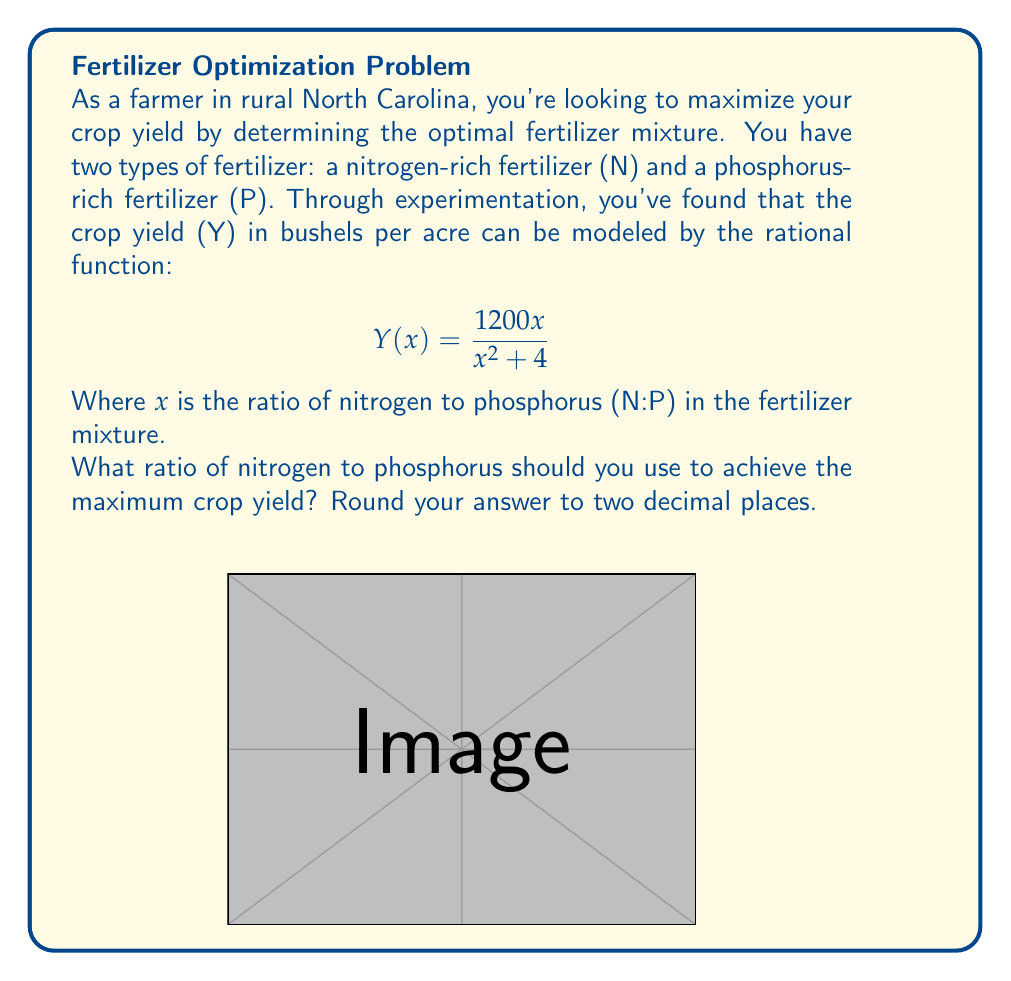Give your solution to this math problem. To find the maximum yield, we need to determine the x-value where the function Y(x) reaches its peak. We can do this by following these steps:

1) First, let's find the derivative of Y(x):
   $$ Y'(x) = \frac{(1200)(x^2 + 4) - 1200x(2x)}{(x^2 + 4)^2} $$
   $$ = \frac{1200x^2 + 4800 - 2400x^2}{(x^2 + 4)^2} $$
   $$ = \frac{4800 - 1200x^2}{(x^2 + 4)^2} $$

2) To find the maximum, set Y'(x) = 0 and solve for x:
   $$ \frac{4800 - 1200x^2}{(x^2 + 4)^2} = 0 $$
   $$ 4800 - 1200x^2 = 0 $$
   $$ 1200x^2 = 4800 $$
   $$ x^2 = 4 $$
   $$ x = \pm 2 $$

3) Since we're dealing with a ratio, we only consider the positive solution: x = 2.

4) To confirm this is a maximum (not a minimum), we can check that Y''(2) < 0 or observe that Y(x) approaches 0 as x approaches both 0 and infinity.

Therefore, the optimal ratio of nitrogen to phosphorus is 2:1 or 2.00:1 when rounded to two decimal places.
Answer: 2.00:1 